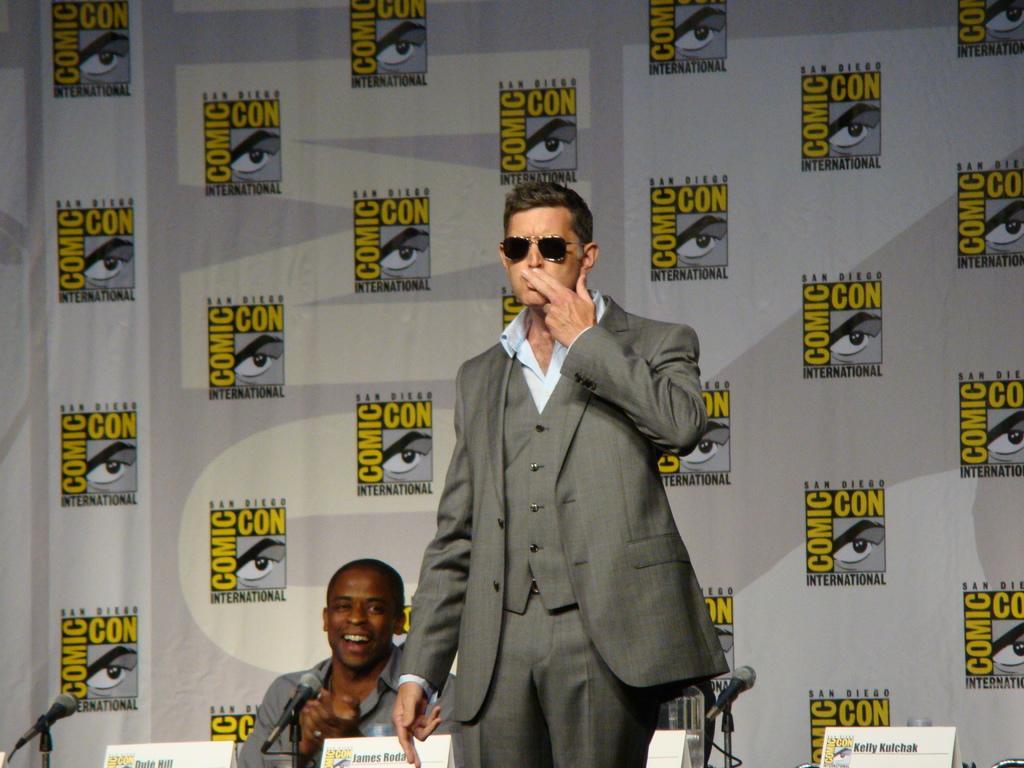Please provide a concise description of this image. In this picture we can see a person in the blazer is standing and another person is sitting. In front of the sitting person there are microphones and name plates. Behind the people, it looks like a board. 